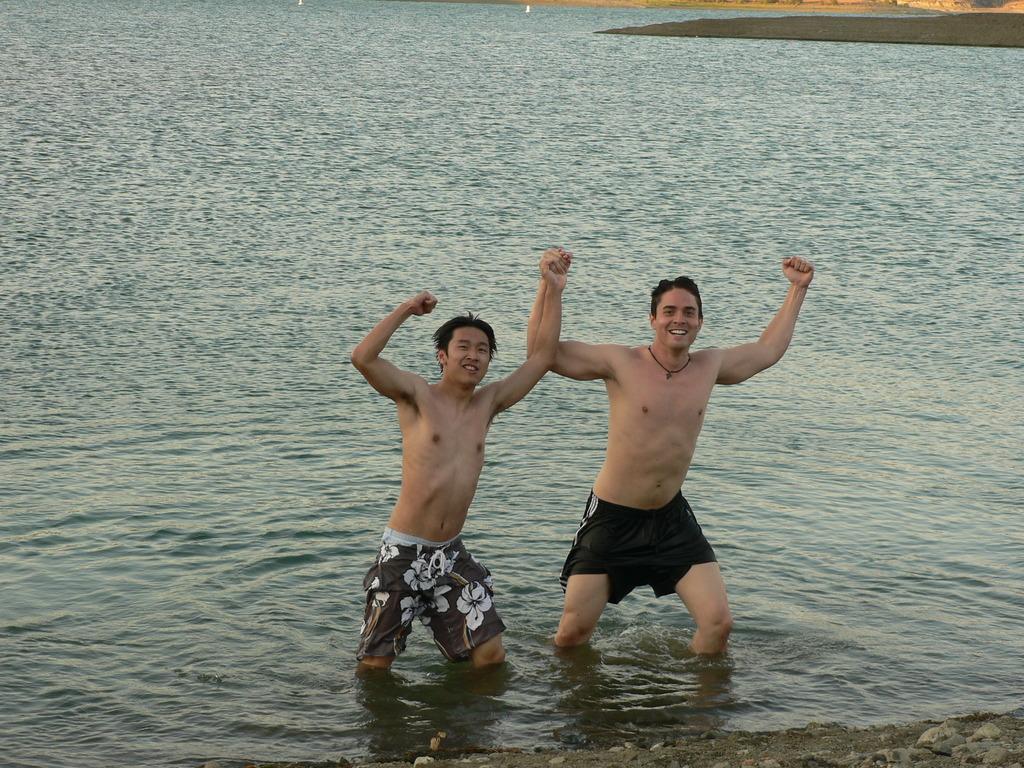In one or two sentences, can you explain what this image depicts? In this image, there are a few people in the water. We can also see the ground and some stones at the bottom. 